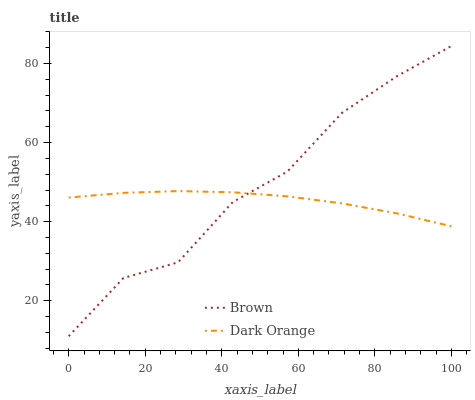Does Dark Orange have the minimum area under the curve?
Answer yes or no. Yes. Does Brown have the maximum area under the curve?
Answer yes or no. Yes. Does Dark Orange have the maximum area under the curve?
Answer yes or no. No. Is Dark Orange the smoothest?
Answer yes or no. Yes. Is Brown the roughest?
Answer yes or no. Yes. Is Dark Orange the roughest?
Answer yes or no. No. Does Brown have the lowest value?
Answer yes or no. Yes. Does Dark Orange have the lowest value?
Answer yes or no. No. Does Brown have the highest value?
Answer yes or no. Yes. Does Dark Orange have the highest value?
Answer yes or no. No. Does Dark Orange intersect Brown?
Answer yes or no. Yes. Is Dark Orange less than Brown?
Answer yes or no. No. Is Dark Orange greater than Brown?
Answer yes or no. No. 